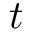<formula> <loc_0><loc_0><loc_500><loc_500>t</formula> 